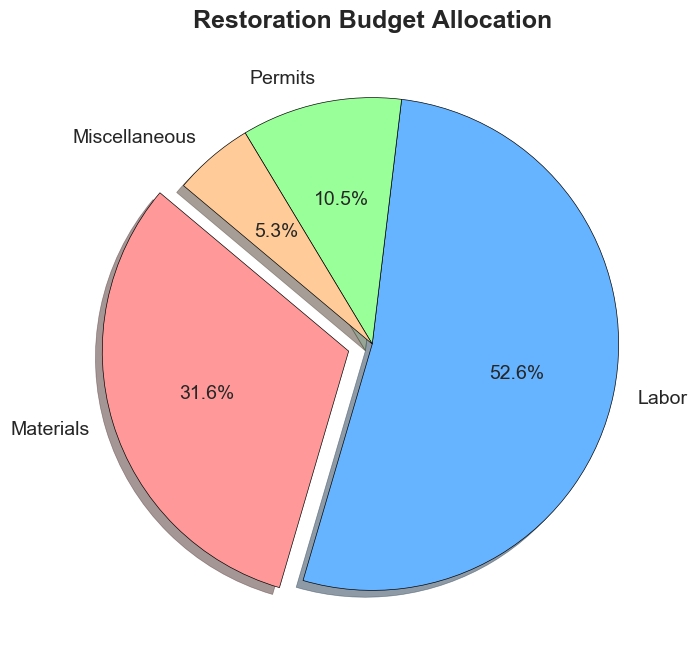What's the largest allocation category in the restoration budget? The pie chart shows that the largest allocation is for Labor, visually indicated by the largest slice of the pie chart.
Answer: Labor What's the difference in budget allocation between Labor and Materials? The chart shows the allocation for Labor is $50,000 and Materials is $30,000. The difference is $50,000 - $30,000.
Answer: $20,000 What percentage of the total budget is allocated to Permits? The pie chart shows the Permits category is 10% of the total budget.
Answer: 10% How much is allocated to categories other than Labor? The pie chart shows the allocation for Materials, Permits, and Miscellaneous. Adding them: $30,000 (Materials) + $10,000 (Permits) + $5,000 (Miscellaneous) = $45,000.
Answer: $45,000 Which category has the smallest allocation in the budget? The pie chart shows the smallest slice is for Miscellaneous, indicating it has the smallest allocation.
Answer: Miscellaneous Are Materials and Permits allocated more than or less than Labor and Miscellaneous combined? Summing Materials and Permits gives $30,000 + $10,000 = $40,000. For Labor and Miscellaneous, $50,000 + $5,000 = $55,000. Comparing the sums, $40,000 < $55,000.
Answer: Less Which category’s slice is visually highlighted/exploded in the pie chart? The pie chart visually highlights the Materials category by "exploding" or separating its slice from the rest.
Answer: Materials What fraction of the total budget is dedicated to Miscellaneous compared to Materials? The pie chart shows Miscellaneous is $5,000 and Materials is $30,000. The fraction is $5,000 / $30,000.
Answer: 1/6 What's the combined budget for Permits and Miscellaneous? The pie chart shows Permits is $10,000 and Miscellaneous is $5,000. Adding them gives $10,000 + $5,000 = $15,000.
Answer: $15,000 What is the sum of the allocations for non-material expenses? Adding Labor, Permits, and Miscellaneous allocations: $50,000 (Labor) + $10,000 (Permits) + $5,000 (Miscellaneous) = $65,000.
Answer: $65,000 